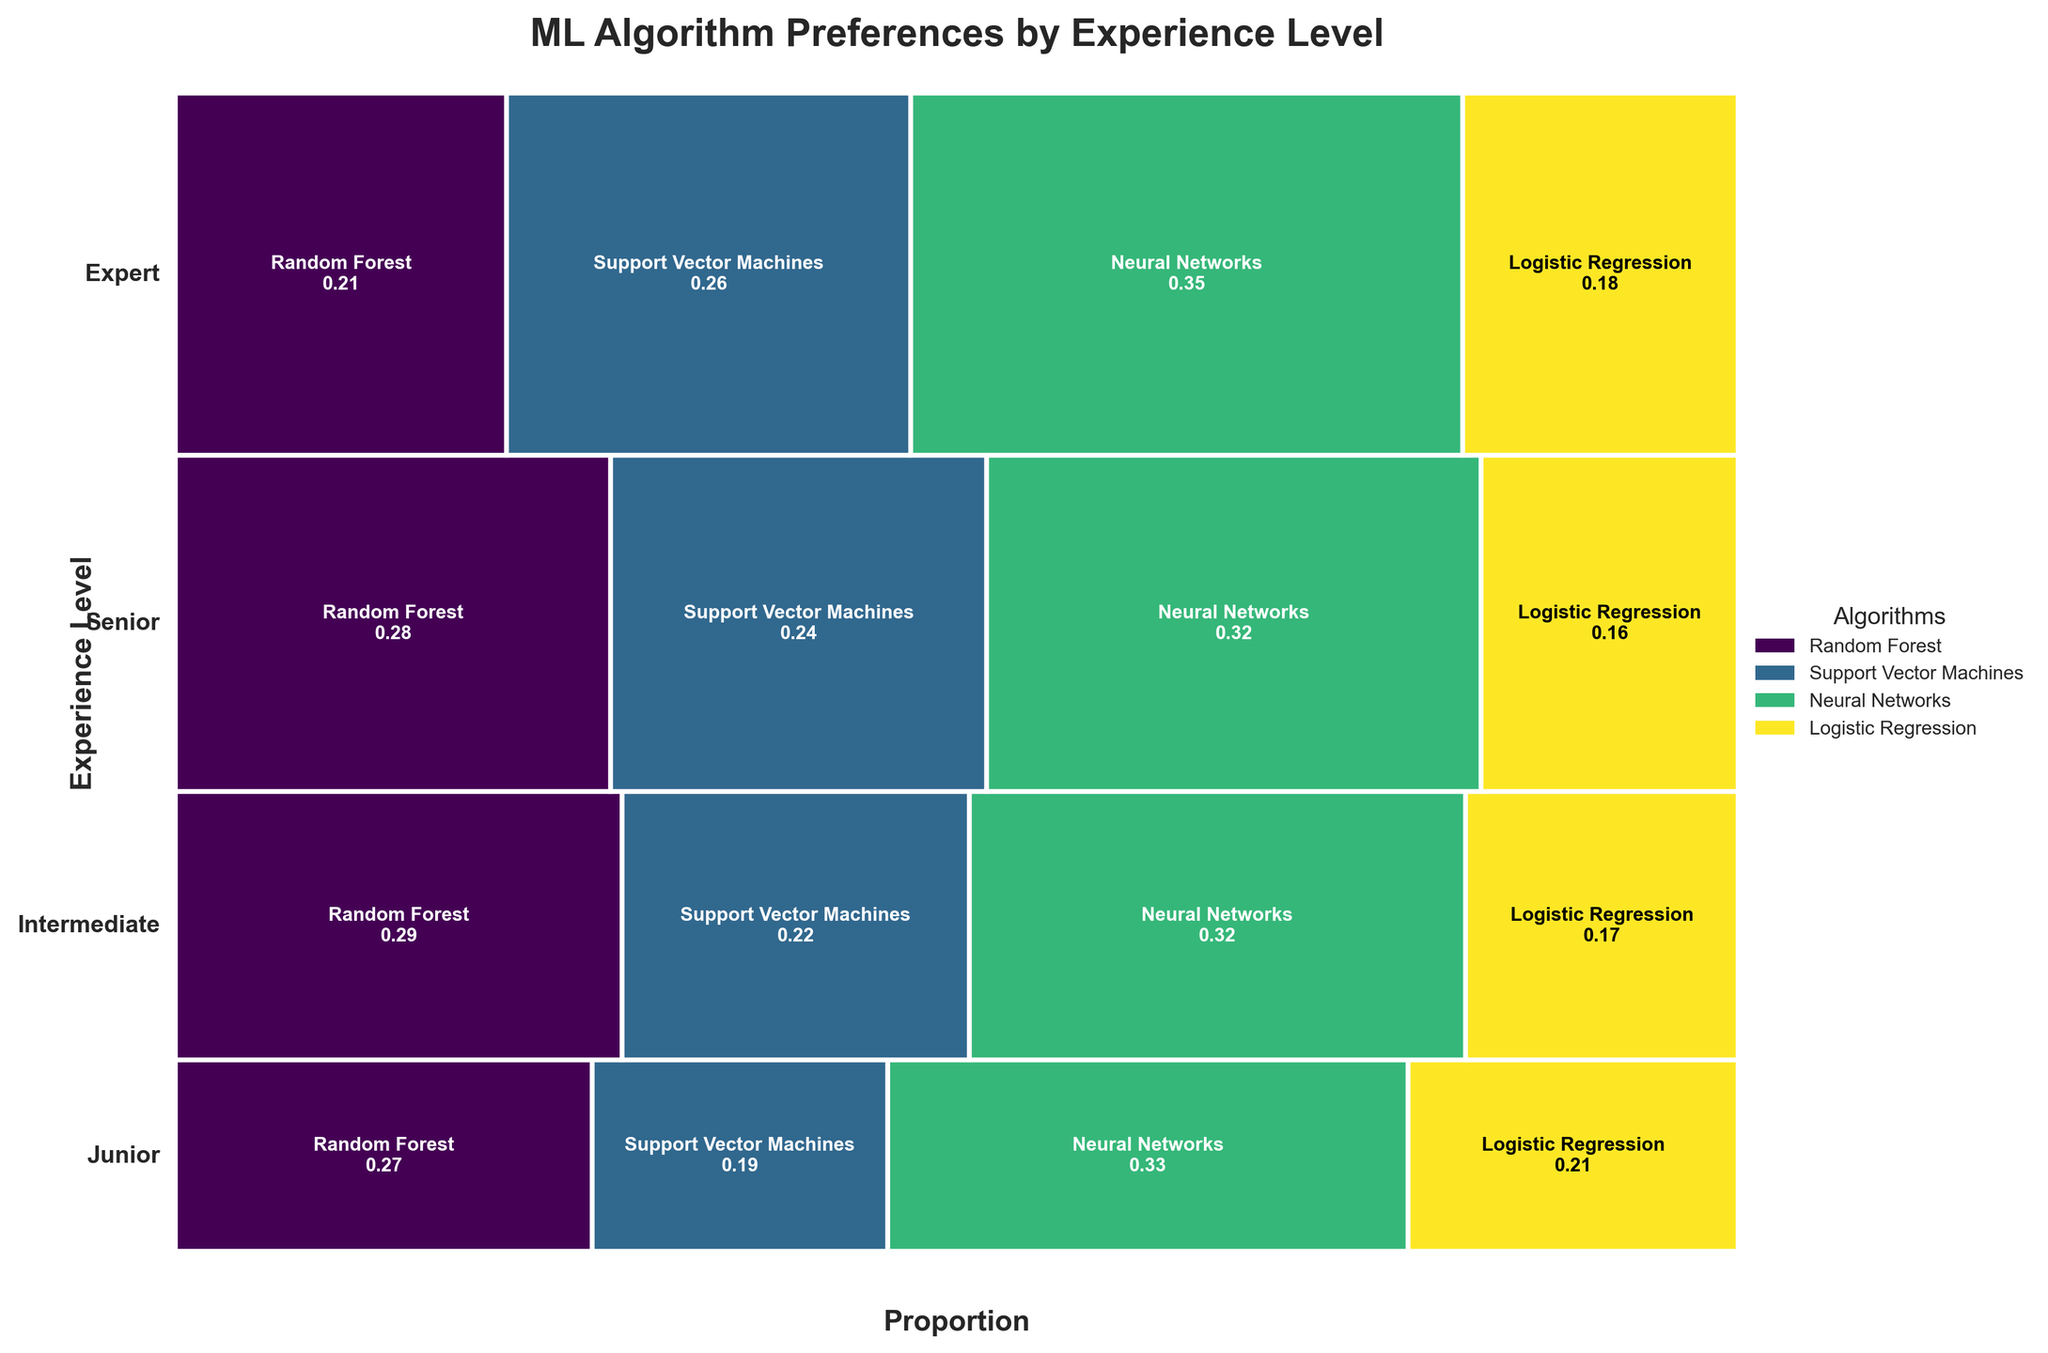Which experience level shows the highest preference for Neural Networks? To determine the highest preference, locate the algorithm "Neural Networks" and compare the segment sizes across all experience levels. The "Neural Networks" segment is visibly largest for "Expert" experience level.
Answer: Expert What algorithm is least preferred by Junior data scientists? Look at the width of the segments for Junior level. The smallest segment corresponds to "Support Vector Machines".
Answer: Support Vector Machines Which experience level has the highest proportion of preferences for Logistic Regression? Compare the vertical heights of Logistic Regression proportions across different experience levels. The height is highest for the "Expert" level.
Answer: Expert What is the total preference count for Random Forest across all experience levels? Sum the provided preference counts for Random Forest: 120 (Junior) + 180 (Intermediate) + 220 (Senior) + 180 (Expert) = 700.
Answer: 700 Do Intermediate data scientists prefer Neural Networks more than Support Vector Machines? Compare widths of Neural Networks and Support Vector Machines for the Intermediate level. The width for Neural Networks is greater than that for Support Vector Machines.
Answer: Yes What's the proportion of preference for Support Vector Machines among Senior data scientists? Locate the Senior support vector machines segment and note the proportion value displayed. It is approximately 0.19.
Answer: 0.19 Which algorithm has the most equal distribution of preference among all experience levels? Compare the proportions of each algorithm across all levels; "Support Vector Machines" shows similar widths across each level.
Answer: Support Vector Machines Which experience level contributes the most to the overall preference count? Add up the respective counts for each level and compare: 
Junior: 120 + 85 + 150 + 95 = 450,
Intermediate: 180 + 140 + 200 + 110 = 630,
Senior: 220 + 190 + 250 + 130 = 790,
Expert: 180 + 220 + 300 + 150 = 850.
The "Expert" level has the highest total.
Answer: Expert 